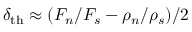Convert formula to latex. <formula><loc_0><loc_0><loc_500><loc_500>\delta _ { t h } \approx ( F _ { n } / F _ { s } - \rho _ { n } / \rho _ { s } ) / 2</formula> 